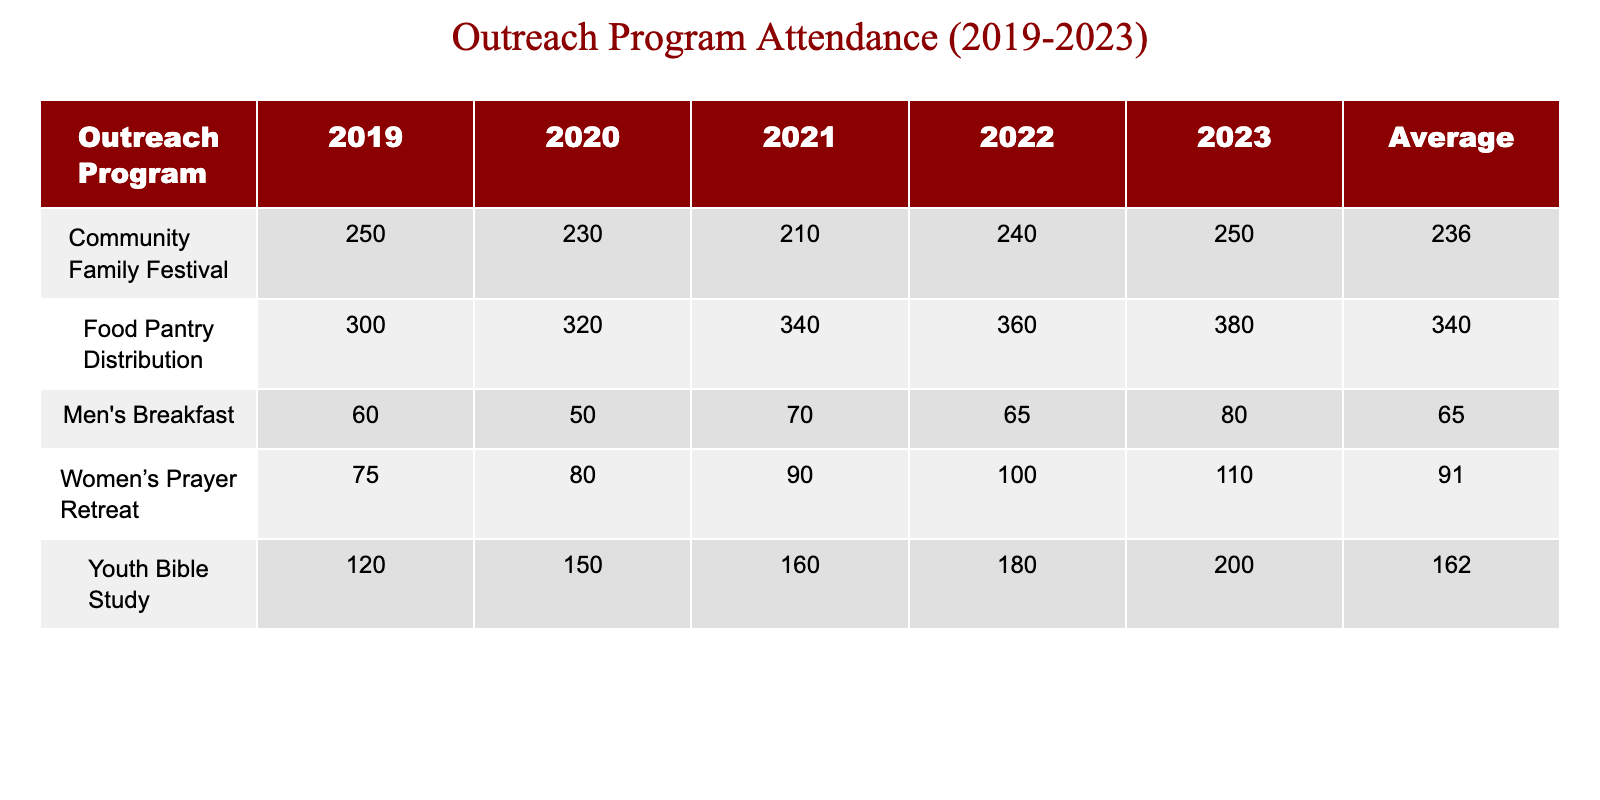What was the attendance for the Food Pantry Distribution in 2022? In the table, I can find the row for the Food Pantry Distribution under the year 2022, and the attendance value listed there is 360.
Answer: 360 Which outreach program had the highest attendance in 2020? By reviewing the attendance values for each program in 2020, the Food Pantry Distribution had the highest attendance of 320, compared to others like the Community Family Festival with 230 and Youth Bible Study with 150.
Answer: Food Pantry Distribution What is the average attendance for Men's Breakfast over the years? The attendance for Men's Breakfast over the years is 60 (2019), 50 (2020), 70 (2021), 65 (2022), and 80 (2023). The sum of these values is 325, and since there are 5 years, the average is 325 divided by 5, which equals 65.
Answer: 65 Did the attendance for Youth Bible Study increase every year? Reviewing the attendance for Youth Bible Study: 120 (2019), 150 (2020), 160 (2021), 180 (2022), and 200 (2023), it's evident that the attendance increased each year, as every subsequent value is higher than the previous year's.
Answer: Yes What is the total attendance for Community Family Festival over the five years? The attendance values for Community Family Festival are 250 (2019), 230 (2020), 210 (2021), 240 (2022), and 250 (2023). Adding these values together gives 250 + 230 + 210 + 240 + 250 = 1180.
Answer: 1180 Which year's outreach programs had a combined attendance lower than 400? Checking each year: 2019 has a total of 250+120+60+75+300=805; 2020 has 230+150+50+80+320=830; 2021 has 210+160+70+90+340=870; 2022 has 240+180+65+100+360=945; and 2023 has 250+200+80+110+380=1020. All years have attendance above 400. Therefore, no year had a combined attendance lower than 400.
Answer: No What year had the greatest improvement in attendance for Women's Prayer Retreat? To find the improvement, I look at the attendance values: 75 (2019), 80 (2020), 90 (2021), 100 (2022), and 110 (2023). The increase from 2019 to 2023 is 110-75=35, while the increase from 2022 to 2023 is 110-100=10. Thus, the greatest improvement occurred from 2019 to 2023.
Answer: 2019 to 2023 Is the average attendance for Food Pantry Distribution above 350? The attendance values for Food Pantry Distribution are 300 (2019), 320 (2020), 340 (2021), 360 (2022), and 380 (2023). To find the average, we sum these values: 300 + 320 + 340 + 360 + 380 = 1700 and then divide by 5 gives us 1700/5 = 340. Thus, the average attendance is 340, which is not above 350.
Answer: No 